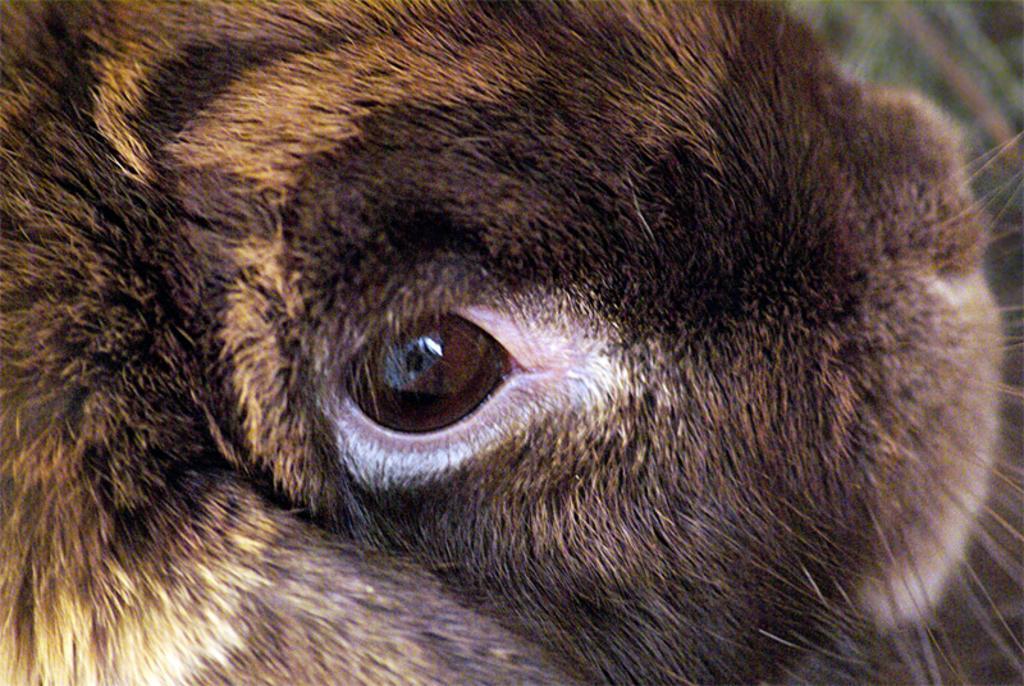Describe this image in one or two sentences. In this picture I can see an eye of an animal and I can see the fur, which is of brown color. 